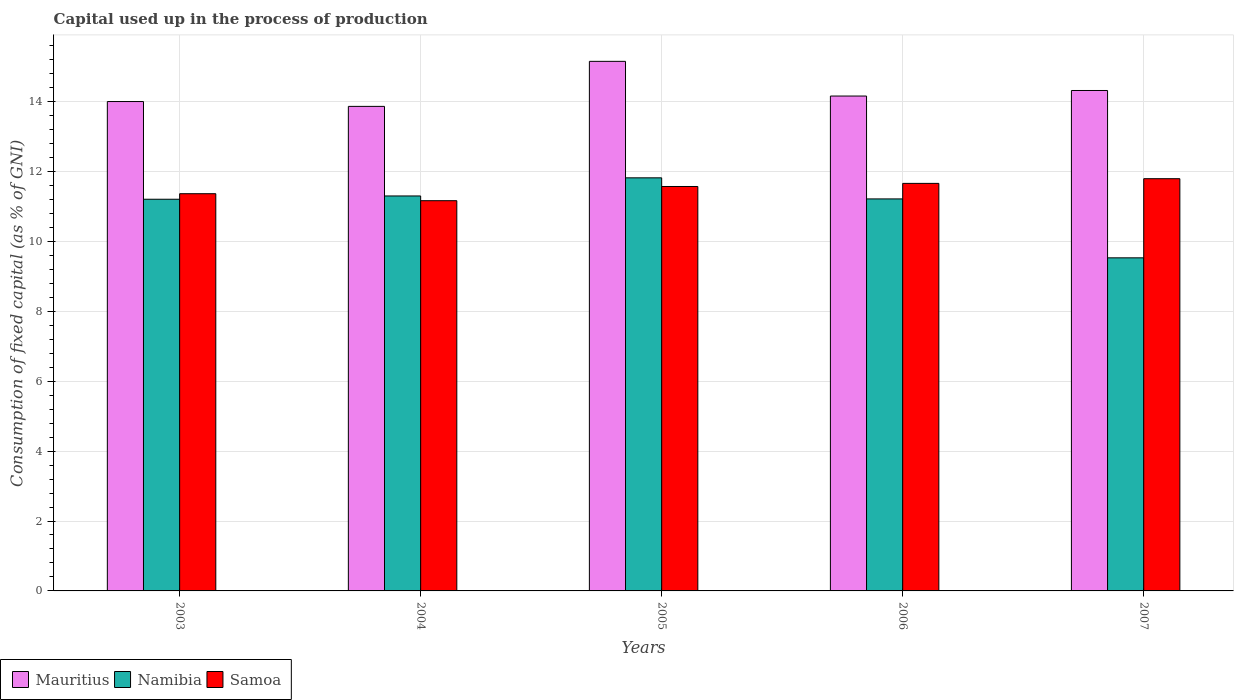How many different coloured bars are there?
Keep it short and to the point. 3. How many groups of bars are there?
Keep it short and to the point. 5. Are the number of bars per tick equal to the number of legend labels?
Make the answer very short. Yes. How many bars are there on the 4th tick from the left?
Make the answer very short. 3. How many bars are there on the 4th tick from the right?
Your response must be concise. 3. In how many cases, is the number of bars for a given year not equal to the number of legend labels?
Your response must be concise. 0. What is the capital used up in the process of production in Mauritius in 2004?
Your answer should be very brief. 13.86. Across all years, what is the maximum capital used up in the process of production in Namibia?
Offer a terse response. 11.82. Across all years, what is the minimum capital used up in the process of production in Mauritius?
Your answer should be very brief. 13.86. In which year was the capital used up in the process of production in Samoa maximum?
Offer a very short reply. 2007. In which year was the capital used up in the process of production in Namibia minimum?
Offer a terse response. 2007. What is the total capital used up in the process of production in Mauritius in the graph?
Offer a very short reply. 71.49. What is the difference between the capital used up in the process of production in Mauritius in 2003 and that in 2007?
Offer a terse response. -0.32. What is the difference between the capital used up in the process of production in Mauritius in 2007 and the capital used up in the process of production in Samoa in 2004?
Give a very brief answer. 3.15. What is the average capital used up in the process of production in Mauritius per year?
Your response must be concise. 14.3. In the year 2006, what is the difference between the capital used up in the process of production in Samoa and capital used up in the process of production in Namibia?
Your answer should be very brief. 0.44. In how many years, is the capital used up in the process of production in Mauritius greater than 4 %?
Keep it short and to the point. 5. What is the ratio of the capital used up in the process of production in Mauritius in 2005 to that in 2007?
Provide a short and direct response. 1.06. What is the difference between the highest and the second highest capital used up in the process of production in Mauritius?
Your answer should be very brief. 0.83. What is the difference between the highest and the lowest capital used up in the process of production in Samoa?
Make the answer very short. 0.63. Is the sum of the capital used up in the process of production in Mauritius in 2003 and 2005 greater than the maximum capital used up in the process of production in Samoa across all years?
Offer a very short reply. Yes. What does the 2nd bar from the left in 2004 represents?
Give a very brief answer. Namibia. What does the 2nd bar from the right in 2003 represents?
Provide a succinct answer. Namibia. Is it the case that in every year, the sum of the capital used up in the process of production in Namibia and capital used up in the process of production in Samoa is greater than the capital used up in the process of production in Mauritius?
Provide a short and direct response. Yes. Are all the bars in the graph horizontal?
Give a very brief answer. No. Does the graph contain any zero values?
Give a very brief answer. No. Does the graph contain grids?
Keep it short and to the point. Yes. How many legend labels are there?
Your answer should be very brief. 3. What is the title of the graph?
Make the answer very short. Capital used up in the process of production. What is the label or title of the Y-axis?
Offer a terse response. Consumption of fixed capital (as % of GNI). What is the Consumption of fixed capital (as % of GNI) of Mauritius in 2003?
Your answer should be compact. 14. What is the Consumption of fixed capital (as % of GNI) of Namibia in 2003?
Offer a terse response. 11.21. What is the Consumption of fixed capital (as % of GNI) in Samoa in 2003?
Your answer should be very brief. 11.36. What is the Consumption of fixed capital (as % of GNI) in Mauritius in 2004?
Provide a succinct answer. 13.86. What is the Consumption of fixed capital (as % of GNI) of Namibia in 2004?
Give a very brief answer. 11.3. What is the Consumption of fixed capital (as % of GNI) of Samoa in 2004?
Make the answer very short. 11.16. What is the Consumption of fixed capital (as % of GNI) in Mauritius in 2005?
Your answer should be very brief. 15.15. What is the Consumption of fixed capital (as % of GNI) of Namibia in 2005?
Keep it short and to the point. 11.82. What is the Consumption of fixed capital (as % of GNI) of Samoa in 2005?
Offer a very short reply. 11.57. What is the Consumption of fixed capital (as % of GNI) in Mauritius in 2006?
Ensure brevity in your answer.  14.16. What is the Consumption of fixed capital (as % of GNI) in Namibia in 2006?
Keep it short and to the point. 11.22. What is the Consumption of fixed capital (as % of GNI) in Samoa in 2006?
Your response must be concise. 11.66. What is the Consumption of fixed capital (as % of GNI) in Mauritius in 2007?
Offer a terse response. 14.32. What is the Consumption of fixed capital (as % of GNI) in Namibia in 2007?
Ensure brevity in your answer.  9.53. What is the Consumption of fixed capital (as % of GNI) of Samoa in 2007?
Offer a very short reply. 11.79. Across all years, what is the maximum Consumption of fixed capital (as % of GNI) in Mauritius?
Your answer should be very brief. 15.15. Across all years, what is the maximum Consumption of fixed capital (as % of GNI) in Namibia?
Provide a short and direct response. 11.82. Across all years, what is the maximum Consumption of fixed capital (as % of GNI) of Samoa?
Offer a very short reply. 11.79. Across all years, what is the minimum Consumption of fixed capital (as % of GNI) of Mauritius?
Your answer should be very brief. 13.86. Across all years, what is the minimum Consumption of fixed capital (as % of GNI) in Namibia?
Provide a short and direct response. 9.53. Across all years, what is the minimum Consumption of fixed capital (as % of GNI) in Samoa?
Offer a terse response. 11.16. What is the total Consumption of fixed capital (as % of GNI) in Mauritius in the graph?
Your response must be concise. 71.49. What is the total Consumption of fixed capital (as % of GNI) in Namibia in the graph?
Make the answer very short. 55.07. What is the total Consumption of fixed capital (as % of GNI) of Samoa in the graph?
Ensure brevity in your answer.  57.55. What is the difference between the Consumption of fixed capital (as % of GNI) of Mauritius in 2003 and that in 2004?
Your response must be concise. 0.14. What is the difference between the Consumption of fixed capital (as % of GNI) in Namibia in 2003 and that in 2004?
Your answer should be very brief. -0.09. What is the difference between the Consumption of fixed capital (as % of GNI) in Samoa in 2003 and that in 2004?
Make the answer very short. 0.2. What is the difference between the Consumption of fixed capital (as % of GNI) in Mauritius in 2003 and that in 2005?
Make the answer very short. -1.15. What is the difference between the Consumption of fixed capital (as % of GNI) in Namibia in 2003 and that in 2005?
Offer a very short reply. -0.61. What is the difference between the Consumption of fixed capital (as % of GNI) of Samoa in 2003 and that in 2005?
Your answer should be very brief. -0.21. What is the difference between the Consumption of fixed capital (as % of GNI) in Mauritius in 2003 and that in 2006?
Offer a very short reply. -0.16. What is the difference between the Consumption of fixed capital (as % of GNI) in Namibia in 2003 and that in 2006?
Provide a succinct answer. -0.01. What is the difference between the Consumption of fixed capital (as % of GNI) of Samoa in 2003 and that in 2006?
Offer a terse response. -0.3. What is the difference between the Consumption of fixed capital (as % of GNI) in Mauritius in 2003 and that in 2007?
Your answer should be compact. -0.32. What is the difference between the Consumption of fixed capital (as % of GNI) in Namibia in 2003 and that in 2007?
Offer a very short reply. 1.68. What is the difference between the Consumption of fixed capital (as % of GNI) of Samoa in 2003 and that in 2007?
Your answer should be very brief. -0.43. What is the difference between the Consumption of fixed capital (as % of GNI) in Mauritius in 2004 and that in 2005?
Your response must be concise. -1.29. What is the difference between the Consumption of fixed capital (as % of GNI) in Namibia in 2004 and that in 2005?
Your answer should be compact. -0.52. What is the difference between the Consumption of fixed capital (as % of GNI) of Samoa in 2004 and that in 2005?
Ensure brevity in your answer.  -0.41. What is the difference between the Consumption of fixed capital (as % of GNI) of Mauritius in 2004 and that in 2006?
Offer a terse response. -0.3. What is the difference between the Consumption of fixed capital (as % of GNI) in Namibia in 2004 and that in 2006?
Ensure brevity in your answer.  0.08. What is the difference between the Consumption of fixed capital (as % of GNI) of Samoa in 2004 and that in 2006?
Your response must be concise. -0.5. What is the difference between the Consumption of fixed capital (as % of GNI) in Mauritius in 2004 and that in 2007?
Give a very brief answer. -0.45. What is the difference between the Consumption of fixed capital (as % of GNI) in Namibia in 2004 and that in 2007?
Ensure brevity in your answer.  1.77. What is the difference between the Consumption of fixed capital (as % of GNI) of Samoa in 2004 and that in 2007?
Your response must be concise. -0.63. What is the difference between the Consumption of fixed capital (as % of GNI) in Mauritius in 2005 and that in 2006?
Give a very brief answer. 0.99. What is the difference between the Consumption of fixed capital (as % of GNI) of Namibia in 2005 and that in 2006?
Your answer should be very brief. 0.6. What is the difference between the Consumption of fixed capital (as % of GNI) in Samoa in 2005 and that in 2006?
Your answer should be compact. -0.09. What is the difference between the Consumption of fixed capital (as % of GNI) in Mauritius in 2005 and that in 2007?
Provide a succinct answer. 0.83. What is the difference between the Consumption of fixed capital (as % of GNI) of Namibia in 2005 and that in 2007?
Ensure brevity in your answer.  2.29. What is the difference between the Consumption of fixed capital (as % of GNI) in Samoa in 2005 and that in 2007?
Make the answer very short. -0.22. What is the difference between the Consumption of fixed capital (as % of GNI) of Mauritius in 2006 and that in 2007?
Provide a succinct answer. -0.16. What is the difference between the Consumption of fixed capital (as % of GNI) of Namibia in 2006 and that in 2007?
Make the answer very short. 1.69. What is the difference between the Consumption of fixed capital (as % of GNI) of Samoa in 2006 and that in 2007?
Provide a short and direct response. -0.13. What is the difference between the Consumption of fixed capital (as % of GNI) in Mauritius in 2003 and the Consumption of fixed capital (as % of GNI) in Namibia in 2004?
Provide a succinct answer. 2.7. What is the difference between the Consumption of fixed capital (as % of GNI) in Mauritius in 2003 and the Consumption of fixed capital (as % of GNI) in Samoa in 2004?
Provide a succinct answer. 2.84. What is the difference between the Consumption of fixed capital (as % of GNI) of Namibia in 2003 and the Consumption of fixed capital (as % of GNI) of Samoa in 2004?
Provide a succinct answer. 0.04. What is the difference between the Consumption of fixed capital (as % of GNI) in Mauritius in 2003 and the Consumption of fixed capital (as % of GNI) in Namibia in 2005?
Your answer should be very brief. 2.18. What is the difference between the Consumption of fixed capital (as % of GNI) in Mauritius in 2003 and the Consumption of fixed capital (as % of GNI) in Samoa in 2005?
Make the answer very short. 2.43. What is the difference between the Consumption of fixed capital (as % of GNI) in Namibia in 2003 and the Consumption of fixed capital (as % of GNI) in Samoa in 2005?
Offer a very short reply. -0.36. What is the difference between the Consumption of fixed capital (as % of GNI) in Mauritius in 2003 and the Consumption of fixed capital (as % of GNI) in Namibia in 2006?
Your response must be concise. 2.79. What is the difference between the Consumption of fixed capital (as % of GNI) in Mauritius in 2003 and the Consumption of fixed capital (as % of GNI) in Samoa in 2006?
Your answer should be very brief. 2.34. What is the difference between the Consumption of fixed capital (as % of GNI) of Namibia in 2003 and the Consumption of fixed capital (as % of GNI) of Samoa in 2006?
Provide a short and direct response. -0.45. What is the difference between the Consumption of fixed capital (as % of GNI) of Mauritius in 2003 and the Consumption of fixed capital (as % of GNI) of Namibia in 2007?
Your answer should be compact. 4.47. What is the difference between the Consumption of fixed capital (as % of GNI) of Mauritius in 2003 and the Consumption of fixed capital (as % of GNI) of Samoa in 2007?
Give a very brief answer. 2.21. What is the difference between the Consumption of fixed capital (as % of GNI) in Namibia in 2003 and the Consumption of fixed capital (as % of GNI) in Samoa in 2007?
Your answer should be very brief. -0.59. What is the difference between the Consumption of fixed capital (as % of GNI) of Mauritius in 2004 and the Consumption of fixed capital (as % of GNI) of Namibia in 2005?
Keep it short and to the point. 2.04. What is the difference between the Consumption of fixed capital (as % of GNI) in Mauritius in 2004 and the Consumption of fixed capital (as % of GNI) in Samoa in 2005?
Provide a succinct answer. 2.29. What is the difference between the Consumption of fixed capital (as % of GNI) of Namibia in 2004 and the Consumption of fixed capital (as % of GNI) of Samoa in 2005?
Offer a terse response. -0.27. What is the difference between the Consumption of fixed capital (as % of GNI) in Mauritius in 2004 and the Consumption of fixed capital (as % of GNI) in Namibia in 2006?
Provide a short and direct response. 2.65. What is the difference between the Consumption of fixed capital (as % of GNI) of Mauritius in 2004 and the Consumption of fixed capital (as % of GNI) of Samoa in 2006?
Ensure brevity in your answer.  2.2. What is the difference between the Consumption of fixed capital (as % of GNI) in Namibia in 2004 and the Consumption of fixed capital (as % of GNI) in Samoa in 2006?
Provide a short and direct response. -0.36. What is the difference between the Consumption of fixed capital (as % of GNI) of Mauritius in 2004 and the Consumption of fixed capital (as % of GNI) of Namibia in 2007?
Your answer should be very brief. 4.33. What is the difference between the Consumption of fixed capital (as % of GNI) in Mauritius in 2004 and the Consumption of fixed capital (as % of GNI) in Samoa in 2007?
Your response must be concise. 2.07. What is the difference between the Consumption of fixed capital (as % of GNI) in Namibia in 2004 and the Consumption of fixed capital (as % of GNI) in Samoa in 2007?
Keep it short and to the point. -0.49. What is the difference between the Consumption of fixed capital (as % of GNI) in Mauritius in 2005 and the Consumption of fixed capital (as % of GNI) in Namibia in 2006?
Your answer should be very brief. 3.94. What is the difference between the Consumption of fixed capital (as % of GNI) of Mauritius in 2005 and the Consumption of fixed capital (as % of GNI) of Samoa in 2006?
Give a very brief answer. 3.49. What is the difference between the Consumption of fixed capital (as % of GNI) in Namibia in 2005 and the Consumption of fixed capital (as % of GNI) in Samoa in 2006?
Your response must be concise. 0.16. What is the difference between the Consumption of fixed capital (as % of GNI) in Mauritius in 2005 and the Consumption of fixed capital (as % of GNI) in Namibia in 2007?
Ensure brevity in your answer.  5.62. What is the difference between the Consumption of fixed capital (as % of GNI) of Mauritius in 2005 and the Consumption of fixed capital (as % of GNI) of Samoa in 2007?
Give a very brief answer. 3.36. What is the difference between the Consumption of fixed capital (as % of GNI) of Namibia in 2005 and the Consumption of fixed capital (as % of GNI) of Samoa in 2007?
Keep it short and to the point. 0.02. What is the difference between the Consumption of fixed capital (as % of GNI) of Mauritius in 2006 and the Consumption of fixed capital (as % of GNI) of Namibia in 2007?
Offer a very short reply. 4.63. What is the difference between the Consumption of fixed capital (as % of GNI) of Mauritius in 2006 and the Consumption of fixed capital (as % of GNI) of Samoa in 2007?
Offer a very short reply. 2.36. What is the difference between the Consumption of fixed capital (as % of GNI) in Namibia in 2006 and the Consumption of fixed capital (as % of GNI) in Samoa in 2007?
Provide a short and direct response. -0.58. What is the average Consumption of fixed capital (as % of GNI) of Mauritius per year?
Give a very brief answer. 14.3. What is the average Consumption of fixed capital (as % of GNI) in Namibia per year?
Offer a very short reply. 11.01. What is the average Consumption of fixed capital (as % of GNI) of Samoa per year?
Offer a very short reply. 11.51. In the year 2003, what is the difference between the Consumption of fixed capital (as % of GNI) in Mauritius and Consumption of fixed capital (as % of GNI) in Namibia?
Your answer should be compact. 2.8. In the year 2003, what is the difference between the Consumption of fixed capital (as % of GNI) in Mauritius and Consumption of fixed capital (as % of GNI) in Samoa?
Your answer should be compact. 2.64. In the year 2003, what is the difference between the Consumption of fixed capital (as % of GNI) of Namibia and Consumption of fixed capital (as % of GNI) of Samoa?
Offer a terse response. -0.16. In the year 2004, what is the difference between the Consumption of fixed capital (as % of GNI) in Mauritius and Consumption of fixed capital (as % of GNI) in Namibia?
Provide a short and direct response. 2.56. In the year 2004, what is the difference between the Consumption of fixed capital (as % of GNI) of Mauritius and Consumption of fixed capital (as % of GNI) of Samoa?
Provide a succinct answer. 2.7. In the year 2004, what is the difference between the Consumption of fixed capital (as % of GNI) in Namibia and Consumption of fixed capital (as % of GNI) in Samoa?
Your answer should be compact. 0.14. In the year 2005, what is the difference between the Consumption of fixed capital (as % of GNI) in Mauritius and Consumption of fixed capital (as % of GNI) in Namibia?
Provide a short and direct response. 3.33. In the year 2005, what is the difference between the Consumption of fixed capital (as % of GNI) of Mauritius and Consumption of fixed capital (as % of GNI) of Samoa?
Give a very brief answer. 3.58. In the year 2005, what is the difference between the Consumption of fixed capital (as % of GNI) in Namibia and Consumption of fixed capital (as % of GNI) in Samoa?
Provide a succinct answer. 0.25. In the year 2006, what is the difference between the Consumption of fixed capital (as % of GNI) of Mauritius and Consumption of fixed capital (as % of GNI) of Namibia?
Give a very brief answer. 2.94. In the year 2006, what is the difference between the Consumption of fixed capital (as % of GNI) in Mauritius and Consumption of fixed capital (as % of GNI) in Samoa?
Your answer should be compact. 2.5. In the year 2006, what is the difference between the Consumption of fixed capital (as % of GNI) in Namibia and Consumption of fixed capital (as % of GNI) in Samoa?
Ensure brevity in your answer.  -0.44. In the year 2007, what is the difference between the Consumption of fixed capital (as % of GNI) in Mauritius and Consumption of fixed capital (as % of GNI) in Namibia?
Give a very brief answer. 4.79. In the year 2007, what is the difference between the Consumption of fixed capital (as % of GNI) of Mauritius and Consumption of fixed capital (as % of GNI) of Samoa?
Provide a succinct answer. 2.52. In the year 2007, what is the difference between the Consumption of fixed capital (as % of GNI) in Namibia and Consumption of fixed capital (as % of GNI) in Samoa?
Offer a very short reply. -2.26. What is the ratio of the Consumption of fixed capital (as % of GNI) in Mauritius in 2003 to that in 2004?
Provide a succinct answer. 1.01. What is the ratio of the Consumption of fixed capital (as % of GNI) in Namibia in 2003 to that in 2004?
Ensure brevity in your answer.  0.99. What is the ratio of the Consumption of fixed capital (as % of GNI) in Samoa in 2003 to that in 2004?
Make the answer very short. 1.02. What is the ratio of the Consumption of fixed capital (as % of GNI) in Mauritius in 2003 to that in 2005?
Your answer should be very brief. 0.92. What is the ratio of the Consumption of fixed capital (as % of GNI) in Namibia in 2003 to that in 2005?
Offer a terse response. 0.95. What is the ratio of the Consumption of fixed capital (as % of GNI) of Samoa in 2003 to that in 2005?
Your response must be concise. 0.98. What is the ratio of the Consumption of fixed capital (as % of GNI) of Mauritius in 2003 to that in 2006?
Ensure brevity in your answer.  0.99. What is the ratio of the Consumption of fixed capital (as % of GNI) in Namibia in 2003 to that in 2006?
Offer a terse response. 1. What is the ratio of the Consumption of fixed capital (as % of GNI) in Samoa in 2003 to that in 2006?
Your response must be concise. 0.97. What is the ratio of the Consumption of fixed capital (as % of GNI) of Mauritius in 2003 to that in 2007?
Offer a very short reply. 0.98. What is the ratio of the Consumption of fixed capital (as % of GNI) in Namibia in 2003 to that in 2007?
Your response must be concise. 1.18. What is the ratio of the Consumption of fixed capital (as % of GNI) in Samoa in 2003 to that in 2007?
Your response must be concise. 0.96. What is the ratio of the Consumption of fixed capital (as % of GNI) of Mauritius in 2004 to that in 2005?
Your answer should be compact. 0.92. What is the ratio of the Consumption of fixed capital (as % of GNI) in Namibia in 2004 to that in 2005?
Give a very brief answer. 0.96. What is the ratio of the Consumption of fixed capital (as % of GNI) in Samoa in 2004 to that in 2005?
Your response must be concise. 0.96. What is the ratio of the Consumption of fixed capital (as % of GNI) in Mauritius in 2004 to that in 2006?
Offer a terse response. 0.98. What is the ratio of the Consumption of fixed capital (as % of GNI) of Namibia in 2004 to that in 2006?
Offer a terse response. 1.01. What is the ratio of the Consumption of fixed capital (as % of GNI) in Samoa in 2004 to that in 2006?
Give a very brief answer. 0.96. What is the ratio of the Consumption of fixed capital (as % of GNI) in Mauritius in 2004 to that in 2007?
Give a very brief answer. 0.97. What is the ratio of the Consumption of fixed capital (as % of GNI) in Namibia in 2004 to that in 2007?
Ensure brevity in your answer.  1.19. What is the ratio of the Consumption of fixed capital (as % of GNI) in Samoa in 2004 to that in 2007?
Offer a very short reply. 0.95. What is the ratio of the Consumption of fixed capital (as % of GNI) in Mauritius in 2005 to that in 2006?
Keep it short and to the point. 1.07. What is the ratio of the Consumption of fixed capital (as % of GNI) of Namibia in 2005 to that in 2006?
Ensure brevity in your answer.  1.05. What is the ratio of the Consumption of fixed capital (as % of GNI) of Mauritius in 2005 to that in 2007?
Your response must be concise. 1.06. What is the ratio of the Consumption of fixed capital (as % of GNI) in Namibia in 2005 to that in 2007?
Offer a very short reply. 1.24. What is the ratio of the Consumption of fixed capital (as % of GNI) of Samoa in 2005 to that in 2007?
Your answer should be compact. 0.98. What is the ratio of the Consumption of fixed capital (as % of GNI) in Mauritius in 2006 to that in 2007?
Your response must be concise. 0.99. What is the ratio of the Consumption of fixed capital (as % of GNI) in Namibia in 2006 to that in 2007?
Ensure brevity in your answer.  1.18. What is the difference between the highest and the second highest Consumption of fixed capital (as % of GNI) of Mauritius?
Offer a terse response. 0.83. What is the difference between the highest and the second highest Consumption of fixed capital (as % of GNI) of Namibia?
Your answer should be very brief. 0.52. What is the difference between the highest and the second highest Consumption of fixed capital (as % of GNI) of Samoa?
Offer a very short reply. 0.13. What is the difference between the highest and the lowest Consumption of fixed capital (as % of GNI) of Mauritius?
Provide a short and direct response. 1.29. What is the difference between the highest and the lowest Consumption of fixed capital (as % of GNI) in Namibia?
Keep it short and to the point. 2.29. What is the difference between the highest and the lowest Consumption of fixed capital (as % of GNI) of Samoa?
Your response must be concise. 0.63. 